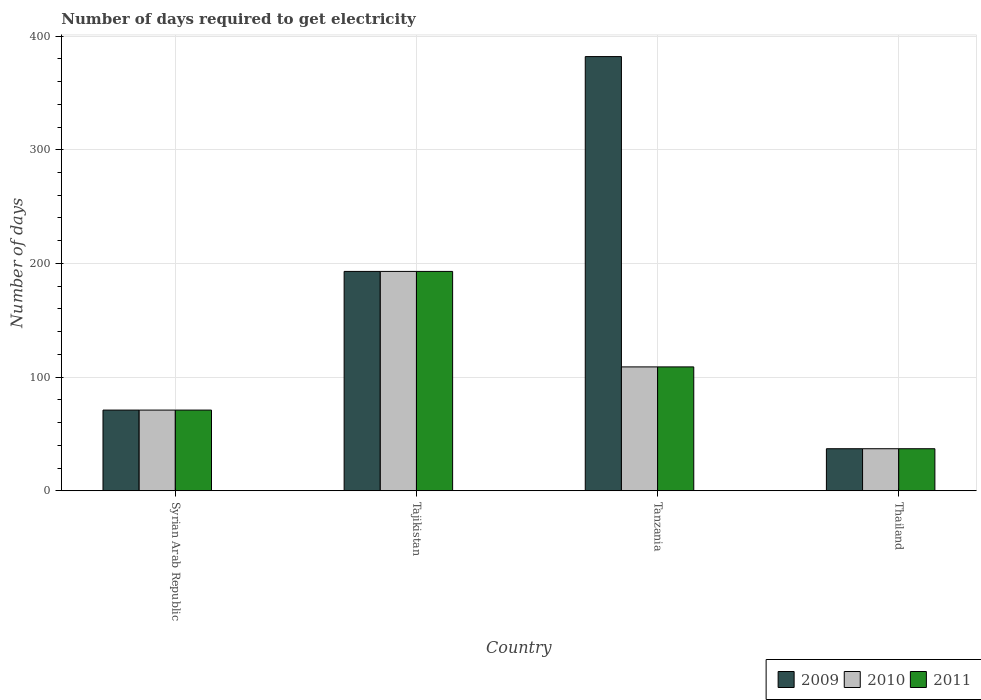How many different coloured bars are there?
Provide a succinct answer. 3. How many groups of bars are there?
Your answer should be compact. 4. Are the number of bars per tick equal to the number of legend labels?
Your answer should be compact. Yes. Are the number of bars on each tick of the X-axis equal?
Offer a terse response. Yes. What is the label of the 4th group of bars from the left?
Offer a very short reply. Thailand. Across all countries, what is the maximum number of days required to get electricity in in 2011?
Your answer should be compact. 193. Across all countries, what is the minimum number of days required to get electricity in in 2010?
Make the answer very short. 37. In which country was the number of days required to get electricity in in 2011 maximum?
Give a very brief answer. Tajikistan. In which country was the number of days required to get electricity in in 2010 minimum?
Make the answer very short. Thailand. What is the total number of days required to get electricity in in 2011 in the graph?
Provide a succinct answer. 410. What is the difference between the number of days required to get electricity in in 2009 in Syrian Arab Republic and that in Tanzania?
Keep it short and to the point. -311. What is the difference between the number of days required to get electricity in in 2011 in Tajikistan and the number of days required to get electricity in in 2009 in Tanzania?
Provide a succinct answer. -189. What is the average number of days required to get electricity in in 2009 per country?
Give a very brief answer. 170.75. What is the difference between the number of days required to get electricity in of/in 2009 and number of days required to get electricity in of/in 2011 in Thailand?
Keep it short and to the point. 0. What is the ratio of the number of days required to get electricity in in 2009 in Tajikistan to that in Thailand?
Your response must be concise. 5.22. Is the difference between the number of days required to get electricity in in 2009 in Syrian Arab Republic and Tanzania greater than the difference between the number of days required to get electricity in in 2011 in Syrian Arab Republic and Tanzania?
Make the answer very short. No. What is the difference between the highest and the lowest number of days required to get electricity in in 2009?
Offer a terse response. 345. In how many countries, is the number of days required to get electricity in in 2010 greater than the average number of days required to get electricity in in 2010 taken over all countries?
Offer a terse response. 2. Is the sum of the number of days required to get electricity in in 2011 in Syrian Arab Republic and Tajikistan greater than the maximum number of days required to get electricity in in 2009 across all countries?
Offer a very short reply. No. What does the 2nd bar from the right in Tajikistan represents?
Give a very brief answer. 2010. How many bars are there?
Provide a succinct answer. 12. Are all the bars in the graph horizontal?
Your answer should be compact. No. What is the difference between two consecutive major ticks on the Y-axis?
Keep it short and to the point. 100. Does the graph contain any zero values?
Give a very brief answer. No. Does the graph contain grids?
Your answer should be very brief. Yes. How many legend labels are there?
Provide a short and direct response. 3. What is the title of the graph?
Ensure brevity in your answer.  Number of days required to get electricity. What is the label or title of the Y-axis?
Provide a succinct answer. Number of days. What is the Number of days of 2010 in Syrian Arab Republic?
Provide a short and direct response. 71. What is the Number of days in 2009 in Tajikistan?
Provide a short and direct response. 193. What is the Number of days in 2010 in Tajikistan?
Your answer should be compact. 193. What is the Number of days of 2011 in Tajikistan?
Your response must be concise. 193. What is the Number of days in 2009 in Tanzania?
Ensure brevity in your answer.  382. What is the Number of days in 2010 in Tanzania?
Provide a short and direct response. 109. What is the Number of days of 2011 in Tanzania?
Your response must be concise. 109. Across all countries, what is the maximum Number of days in 2009?
Provide a short and direct response. 382. Across all countries, what is the maximum Number of days of 2010?
Keep it short and to the point. 193. Across all countries, what is the maximum Number of days of 2011?
Your answer should be compact. 193. Across all countries, what is the minimum Number of days in 2009?
Offer a very short reply. 37. Across all countries, what is the minimum Number of days in 2010?
Your answer should be very brief. 37. Across all countries, what is the minimum Number of days of 2011?
Keep it short and to the point. 37. What is the total Number of days of 2009 in the graph?
Give a very brief answer. 683. What is the total Number of days of 2010 in the graph?
Offer a very short reply. 410. What is the total Number of days in 2011 in the graph?
Your answer should be very brief. 410. What is the difference between the Number of days in 2009 in Syrian Arab Republic and that in Tajikistan?
Your answer should be very brief. -122. What is the difference between the Number of days of 2010 in Syrian Arab Republic and that in Tajikistan?
Your response must be concise. -122. What is the difference between the Number of days in 2011 in Syrian Arab Republic and that in Tajikistan?
Your response must be concise. -122. What is the difference between the Number of days in 2009 in Syrian Arab Republic and that in Tanzania?
Your response must be concise. -311. What is the difference between the Number of days of 2010 in Syrian Arab Republic and that in Tanzania?
Your response must be concise. -38. What is the difference between the Number of days in 2011 in Syrian Arab Republic and that in Tanzania?
Offer a very short reply. -38. What is the difference between the Number of days in 2009 in Syrian Arab Republic and that in Thailand?
Provide a short and direct response. 34. What is the difference between the Number of days in 2010 in Syrian Arab Republic and that in Thailand?
Ensure brevity in your answer.  34. What is the difference between the Number of days of 2009 in Tajikistan and that in Tanzania?
Offer a terse response. -189. What is the difference between the Number of days of 2010 in Tajikistan and that in Tanzania?
Make the answer very short. 84. What is the difference between the Number of days of 2011 in Tajikistan and that in Tanzania?
Give a very brief answer. 84. What is the difference between the Number of days of 2009 in Tajikistan and that in Thailand?
Provide a succinct answer. 156. What is the difference between the Number of days in 2010 in Tajikistan and that in Thailand?
Your answer should be very brief. 156. What is the difference between the Number of days of 2011 in Tajikistan and that in Thailand?
Provide a short and direct response. 156. What is the difference between the Number of days of 2009 in Tanzania and that in Thailand?
Your answer should be very brief. 345. What is the difference between the Number of days of 2010 in Tanzania and that in Thailand?
Your answer should be compact. 72. What is the difference between the Number of days in 2009 in Syrian Arab Republic and the Number of days in 2010 in Tajikistan?
Keep it short and to the point. -122. What is the difference between the Number of days of 2009 in Syrian Arab Republic and the Number of days of 2011 in Tajikistan?
Provide a succinct answer. -122. What is the difference between the Number of days of 2010 in Syrian Arab Republic and the Number of days of 2011 in Tajikistan?
Provide a succinct answer. -122. What is the difference between the Number of days of 2009 in Syrian Arab Republic and the Number of days of 2010 in Tanzania?
Make the answer very short. -38. What is the difference between the Number of days of 2009 in Syrian Arab Republic and the Number of days of 2011 in Tanzania?
Offer a terse response. -38. What is the difference between the Number of days in 2010 in Syrian Arab Republic and the Number of days in 2011 in Tanzania?
Provide a short and direct response. -38. What is the difference between the Number of days of 2010 in Syrian Arab Republic and the Number of days of 2011 in Thailand?
Provide a short and direct response. 34. What is the difference between the Number of days of 2009 in Tajikistan and the Number of days of 2011 in Tanzania?
Offer a very short reply. 84. What is the difference between the Number of days in 2009 in Tajikistan and the Number of days in 2010 in Thailand?
Ensure brevity in your answer.  156. What is the difference between the Number of days of 2009 in Tajikistan and the Number of days of 2011 in Thailand?
Keep it short and to the point. 156. What is the difference between the Number of days of 2010 in Tajikistan and the Number of days of 2011 in Thailand?
Your answer should be compact. 156. What is the difference between the Number of days of 2009 in Tanzania and the Number of days of 2010 in Thailand?
Offer a very short reply. 345. What is the difference between the Number of days of 2009 in Tanzania and the Number of days of 2011 in Thailand?
Provide a succinct answer. 345. What is the average Number of days of 2009 per country?
Your response must be concise. 170.75. What is the average Number of days of 2010 per country?
Ensure brevity in your answer.  102.5. What is the average Number of days of 2011 per country?
Ensure brevity in your answer.  102.5. What is the difference between the Number of days in 2009 and Number of days in 2011 in Syrian Arab Republic?
Your response must be concise. 0. What is the difference between the Number of days of 2009 and Number of days of 2010 in Tajikistan?
Offer a very short reply. 0. What is the difference between the Number of days in 2009 and Number of days in 2011 in Tajikistan?
Provide a short and direct response. 0. What is the difference between the Number of days in 2010 and Number of days in 2011 in Tajikistan?
Offer a terse response. 0. What is the difference between the Number of days of 2009 and Number of days of 2010 in Tanzania?
Your response must be concise. 273. What is the difference between the Number of days in 2009 and Number of days in 2011 in Tanzania?
Ensure brevity in your answer.  273. What is the difference between the Number of days in 2009 and Number of days in 2010 in Thailand?
Offer a terse response. 0. What is the difference between the Number of days of 2010 and Number of days of 2011 in Thailand?
Offer a very short reply. 0. What is the ratio of the Number of days of 2009 in Syrian Arab Republic to that in Tajikistan?
Provide a succinct answer. 0.37. What is the ratio of the Number of days in 2010 in Syrian Arab Republic to that in Tajikistan?
Your answer should be compact. 0.37. What is the ratio of the Number of days in 2011 in Syrian Arab Republic to that in Tajikistan?
Make the answer very short. 0.37. What is the ratio of the Number of days of 2009 in Syrian Arab Republic to that in Tanzania?
Offer a terse response. 0.19. What is the ratio of the Number of days of 2010 in Syrian Arab Republic to that in Tanzania?
Your answer should be very brief. 0.65. What is the ratio of the Number of days of 2011 in Syrian Arab Republic to that in Tanzania?
Your answer should be compact. 0.65. What is the ratio of the Number of days of 2009 in Syrian Arab Republic to that in Thailand?
Give a very brief answer. 1.92. What is the ratio of the Number of days of 2010 in Syrian Arab Republic to that in Thailand?
Offer a terse response. 1.92. What is the ratio of the Number of days in 2011 in Syrian Arab Republic to that in Thailand?
Offer a terse response. 1.92. What is the ratio of the Number of days of 2009 in Tajikistan to that in Tanzania?
Ensure brevity in your answer.  0.51. What is the ratio of the Number of days in 2010 in Tajikistan to that in Tanzania?
Your response must be concise. 1.77. What is the ratio of the Number of days in 2011 in Tajikistan to that in Tanzania?
Offer a very short reply. 1.77. What is the ratio of the Number of days of 2009 in Tajikistan to that in Thailand?
Ensure brevity in your answer.  5.22. What is the ratio of the Number of days of 2010 in Tajikistan to that in Thailand?
Make the answer very short. 5.22. What is the ratio of the Number of days in 2011 in Tajikistan to that in Thailand?
Make the answer very short. 5.22. What is the ratio of the Number of days of 2009 in Tanzania to that in Thailand?
Your answer should be very brief. 10.32. What is the ratio of the Number of days of 2010 in Tanzania to that in Thailand?
Offer a very short reply. 2.95. What is the ratio of the Number of days of 2011 in Tanzania to that in Thailand?
Your answer should be very brief. 2.95. What is the difference between the highest and the second highest Number of days of 2009?
Keep it short and to the point. 189. What is the difference between the highest and the second highest Number of days of 2010?
Give a very brief answer. 84. What is the difference between the highest and the lowest Number of days of 2009?
Your answer should be very brief. 345. What is the difference between the highest and the lowest Number of days in 2010?
Ensure brevity in your answer.  156. What is the difference between the highest and the lowest Number of days in 2011?
Ensure brevity in your answer.  156. 